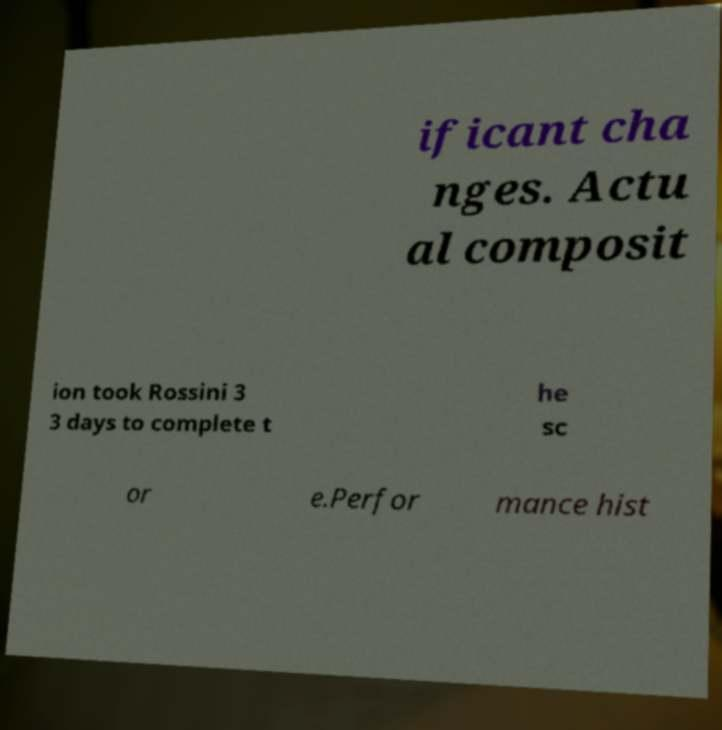I need the written content from this picture converted into text. Can you do that? ificant cha nges. Actu al composit ion took Rossini 3 3 days to complete t he sc or e.Perfor mance hist 